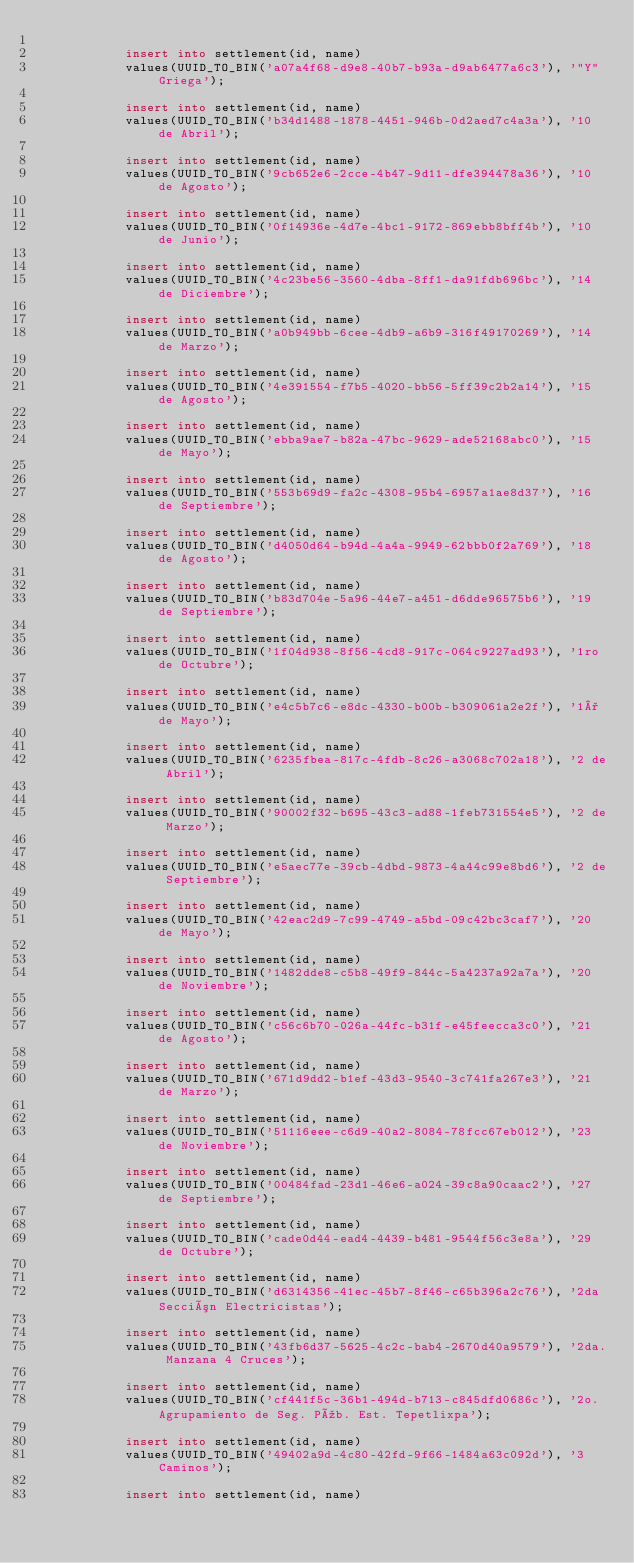Convert code to text. <code><loc_0><loc_0><loc_500><loc_500><_SQL_>
            insert into settlement(id, name)
            values(UUID_TO_BIN('a07a4f68-d9e8-40b7-b93a-d9ab6477a6c3'), '"Y" Griega');
            
            insert into settlement(id, name)
            values(UUID_TO_BIN('b34d1488-1878-4451-946b-0d2aed7c4a3a'), '10 de Abril');
            
            insert into settlement(id, name)
            values(UUID_TO_BIN('9cb652e6-2cce-4b47-9d11-dfe394478a36'), '10 de Agosto');
            
            insert into settlement(id, name)
            values(UUID_TO_BIN('0f14936e-4d7e-4bc1-9172-869ebb8bff4b'), '10 de Junio');
            
            insert into settlement(id, name)
            values(UUID_TO_BIN('4c23be56-3560-4dba-8ff1-da91fdb696bc'), '14 de Diciembre');
            
            insert into settlement(id, name)
            values(UUID_TO_BIN('a0b949bb-6cee-4db9-a6b9-316f49170269'), '14 de Marzo');
            
            insert into settlement(id, name)
            values(UUID_TO_BIN('4e391554-f7b5-4020-bb56-5ff39c2b2a14'), '15 de Agosto');
            
            insert into settlement(id, name)
            values(UUID_TO_BIN('ebba9ae7-b82a-47bc-9629-ade52168abc0'), '15 de Mayo');
            
            insert into settlement(id, name)
            values(UUID_TO_BIN('553b69d9-fa2c-4308-95b4-6957a1ae8d37'), '16 de Septiembre');
            
            insert into settlement(id, name)
            values(UUID_TO_BIN('d4050d64-b94d-4a4a-9949-62bbb0f2a769'), '18 de Agosto');
            
            insert into settlement(id, name)
            values(UUID_TO_BIN('b83d704e-5a96-44e7-a451-d6dde96575b6'), '19 de Septiembre');
            
            insert into settlement(id, name)
            values(UUID_TO_BIN('1f04d938-8f56-4cd8-917c-064c9227ad93'), '1ro de Octubre');
            
            insert into settlement(id, name)
            values(UUID_TO_BIN('e4c5b7c6-e8dc-4330-b00b-b309061a2e2f'), '1° de Mayo');
            
            insert into settlement(id, name)
            values(UUID_TO_BIN('6235fbea-817c-4fdb-8c26-a3068c702a18'), '2 de Abril');
            
            insert into settlement(id, name)
            values(UUID_TO_BIN('90002f32-b695-43c3-ad88-1feb731554e5'), '2 de Marzo');
            
            insert into settlement(id, name)
            values(UUID_TO_BIN('e5aec77e-39cb-4dbd-9873-4a44c99e8bd6'), '2 de Septiembre');
            
            insert into settlement(id, name)
            values(UUID_TO_BIN('42eac2d9-7c99-4749-a5bd-09c42bc3caf7'), '20 de Mayo');
            
            insert into settlement(id, name)
            values(UUID_TO_BIN('1482dde8-c5b8-49f9-844c-5a4237a92a7a'), '20 de Noviembre');
            
            insert into settlement(id, name)
            values(UUID_TO_BIN('c56c6b70-026a-44fc-b31f-e45feecca3c0'), '21 de Agosto');
            
            insert into settlement(id, name)
            values(UUID_TO_BIN('671d9dd2-b1ef-43d3-9540-3c741fa267e3'), '21 de Marzo');
            
            insert into settlement(id, name)
            values(UUID_TO_BIN('51116eee-c6d9-40a2-8084-78fcc67eb012'), '23 de Noviembre');
            
            insert into settlement(id, name)
            values(UUID_TO_BIN('00484fad-23d1-46e6-a024-39c8a90caac2'), '27 de Septiembre');
            
            insert into settlement(id, name)
            values(UUID_TO_BIN('cade0d44-ead4-4439-b481-9544f56c3e8a'), '29 de Octubre');
            
            insert into settlement(id, name)
            values(UUID_TO_BIN('d6314356-41ec-45b7-8f46-c65b396a2c76'), '2da Sección Electricistas');
            
            insert into settlement(id, name)
            values(UUID_TO_BIN('43fb6d37-5625-4c2c-bab4-2670d40a9579'), '2da. Manzana 4 Cruces');
            
            insert into settlement(id, name)
            values(UUID_TO_BIN('cf441f5c-36b1-494d-b713-c845dfd0686c'), '2o. Agrupamiento de Seg. Púb. Est. Tepetlixpa');
            
            insert into settlement(id, name)
            values(UUID_TO_BIN('49402a9d-4c80-42fd-9f66-1484a63c092d'), '3 Caminos');
            
            insert into settlement(id, name)</code> 